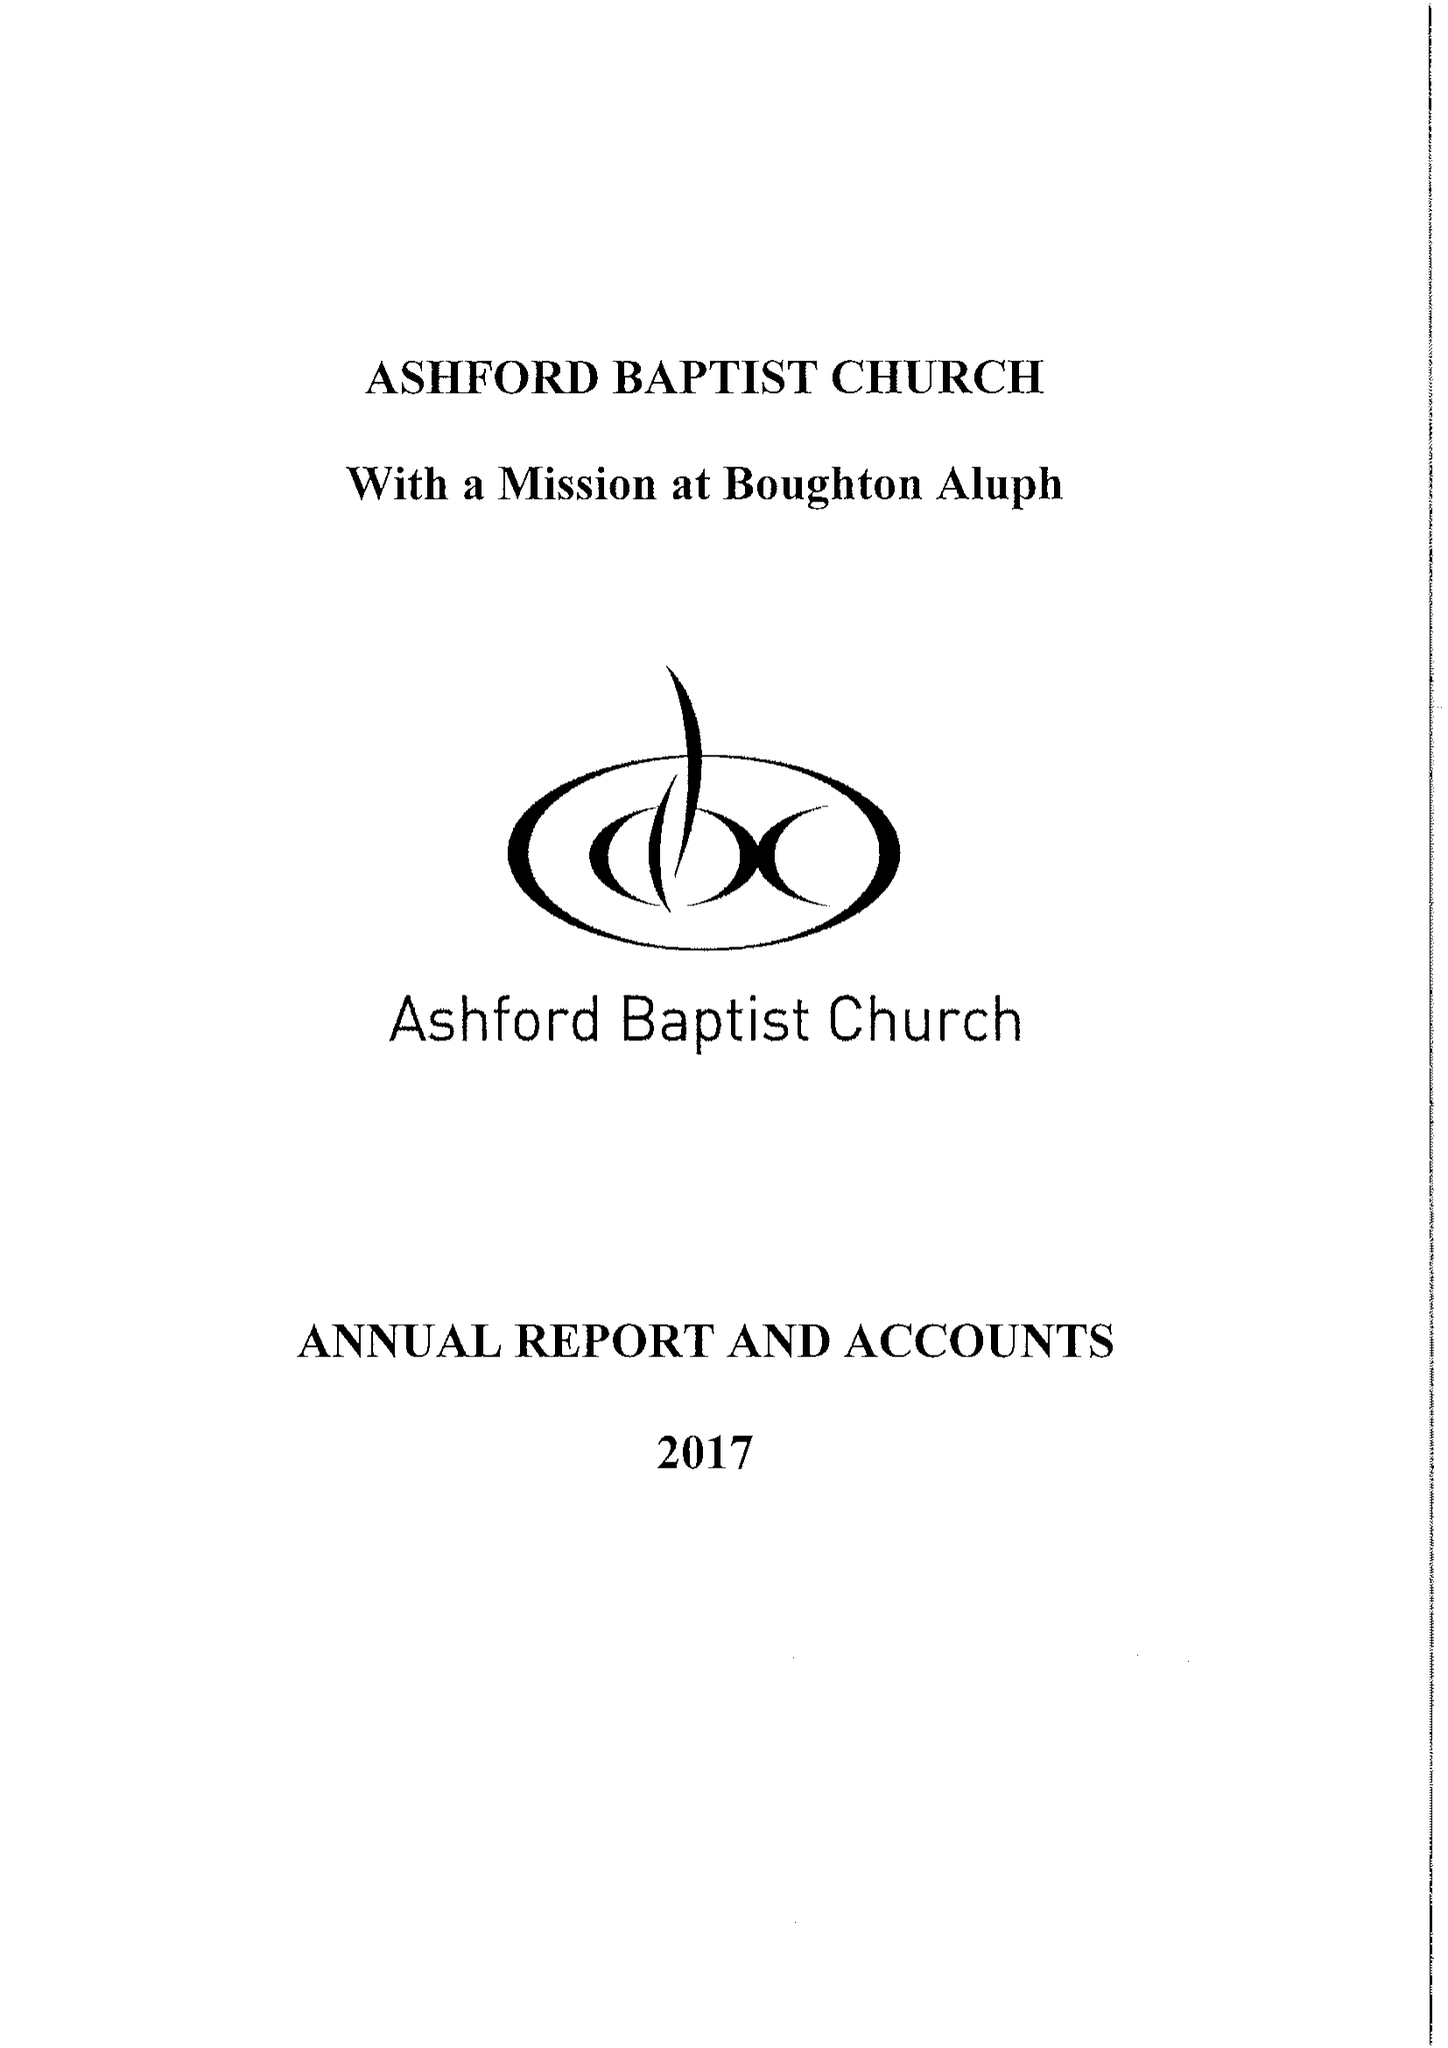What is the value for the charity_number?
Answer the question using a single word or phrase. 1130593 